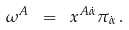Convert formula to latex. <formula><loc_0><loc_0><loc_500><loc_500>\omega ^ { A } \ = \ x ^ { A \dot { \alpha } } \pi _ { \dot { \alpha } } \, .</formula> 